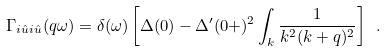<formula> <loc_0><loc_0><loc_500><loc_500>\Gamma _ { i \hat { u } i \hat { u } } ( q \omega ) = \delta ( \omega ) \left [ \Delta ( 0 ) - \Delta ^ { \prime } ( 0 + ) ^ { 2 } \int _ { k } \frac { 1 } { k ^ { 2 } ( k + q ) ^ { 2 } } \right ] \ .</formula> 